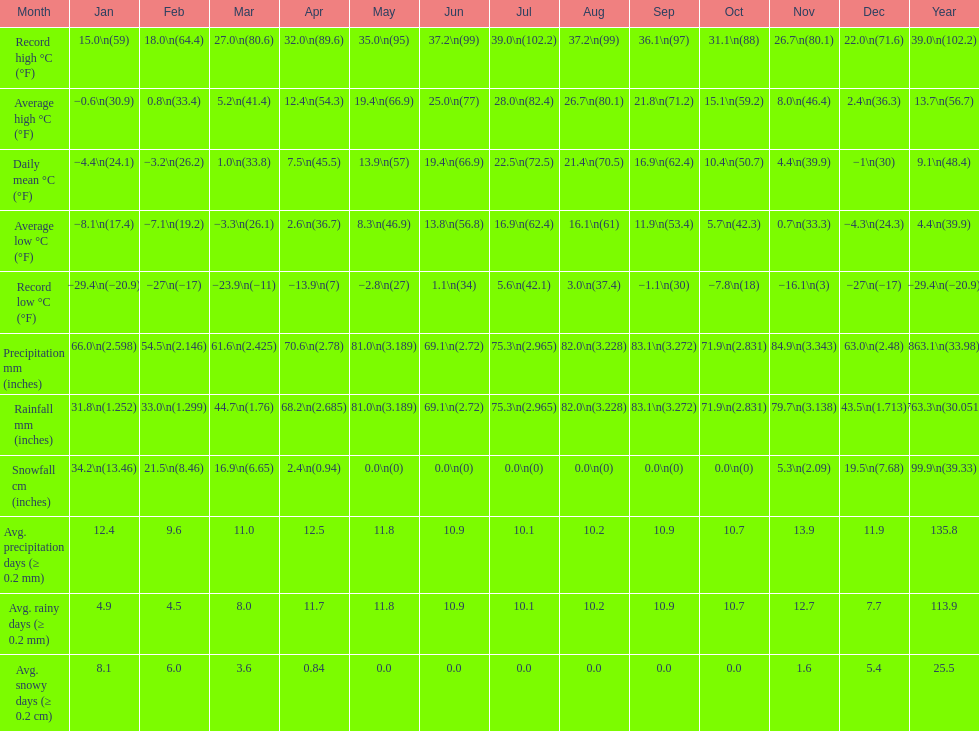0 degrees? 11. 